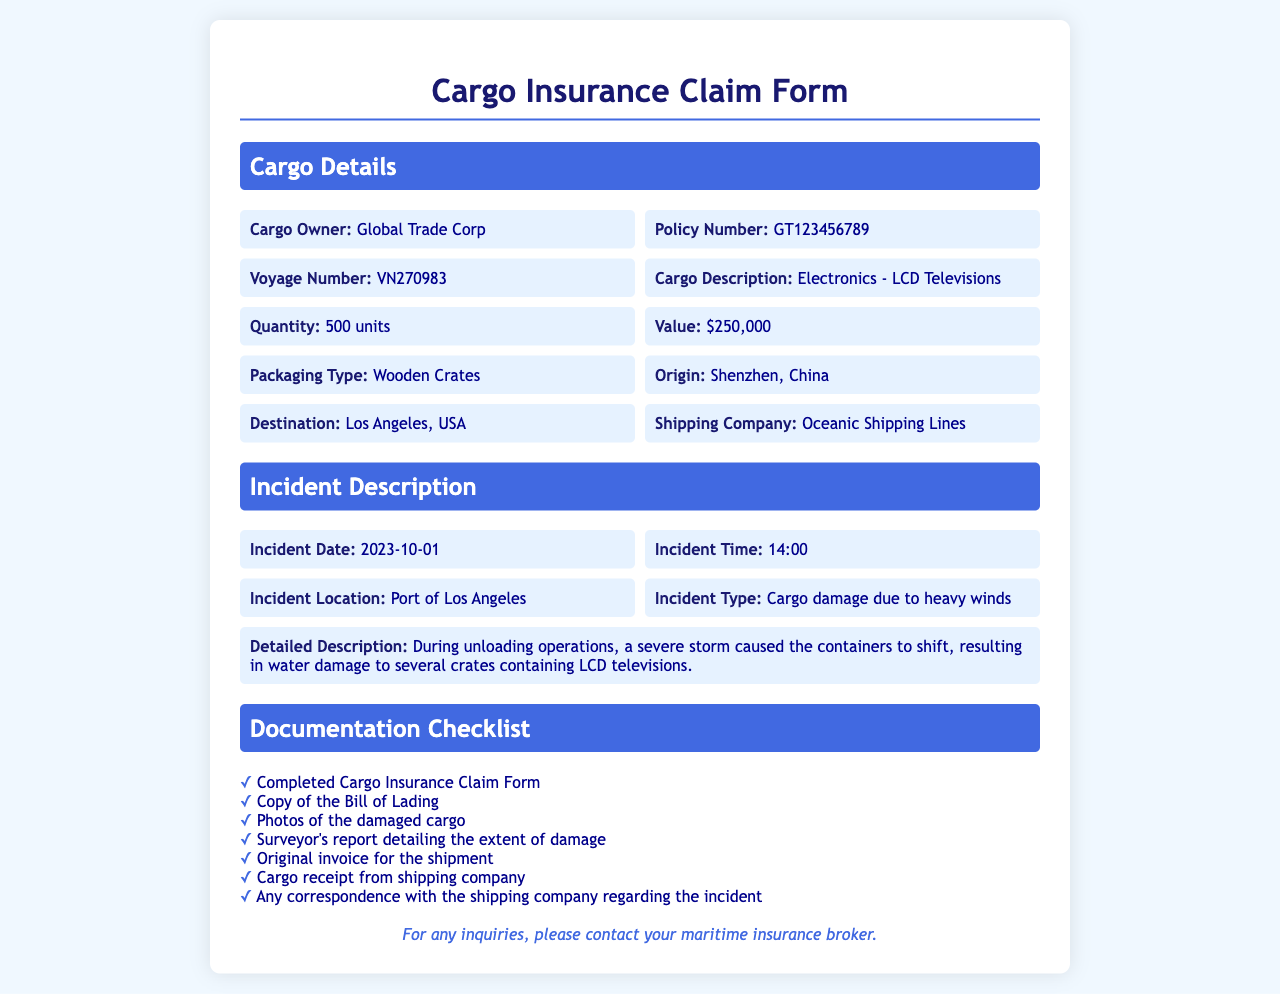what is the cargo owner's name? The cargo owner's name is mentioned under Cargo Details, which is Global Trade Corp.
Answer: Global Trade Corp what is the value of the cargo? The value of the cargo is specified in the Cargo Details section as $250,000.
Answer: $250,000 when did the incident occur? The incident date is clearly stated in the Incident Description section as 2023-10-01.
Answer: 2023-10-01 where was the incident location? The incident location is provided in the Incident Description section, which is the Port of Los Angeles.
Answer: Port of Los Angeles what type of damage occurred to the cargo? The type of damage is mentioned as "Cargo damage due to heavy winds" in the Incident Description section.
Answer: Cargo damage due to heavy winds how many units of cargo were involved? The number of units is found in the Cargo Details section, which specifies 500 units.
Answer: 500 units what is listed as the packaging type? The packaging type is included in the Cargo Details section and is Wooden Crates.
Answer: Wooden Crates what document is required alongside the claim form? The documentation checklist requires a copy of the Bill of Lading among other documents.
Answer: Copy of the Bill of Lading what shipping company was used? The shipping company name is listed in the Cargo Details section as Oceanic Shipping Lines.
Answer: Oceanic Shipping Lines 